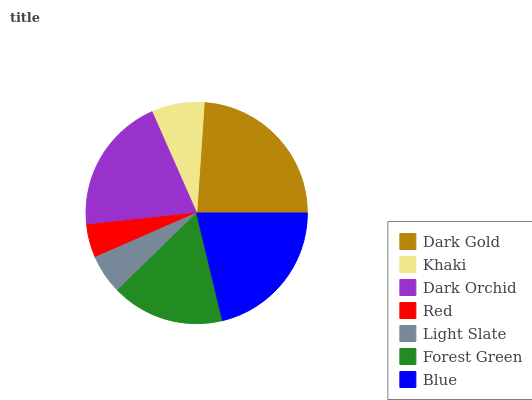Is Red the minimum?
Answer yes or no. Yes. Is Dark Gold the maximum?
Answer yes or no. Yes. Is Khaki the minimum?
Answer yes or no. No. Is Khaki the maximum?
Answer yes or no. No. Is Dark Gold greater than Khaki?
Answer yes or no. Yes. Is Khaki less than Dark Gold?
Answer yes or no. Yes. Is Khaki greater than Dark Gold?
Answer yes or no. No. Is Dark Gold less than Khaki?
Answer yes or no. No. Is Forest Green the high median?
Answer yes or no. Yes. Is Forest Green the low median?
Answer yes or no. Yes. Is Dark Gold the high median?
Answer yes or no. No. Is Red the low median?
Answer yes or no. No. 